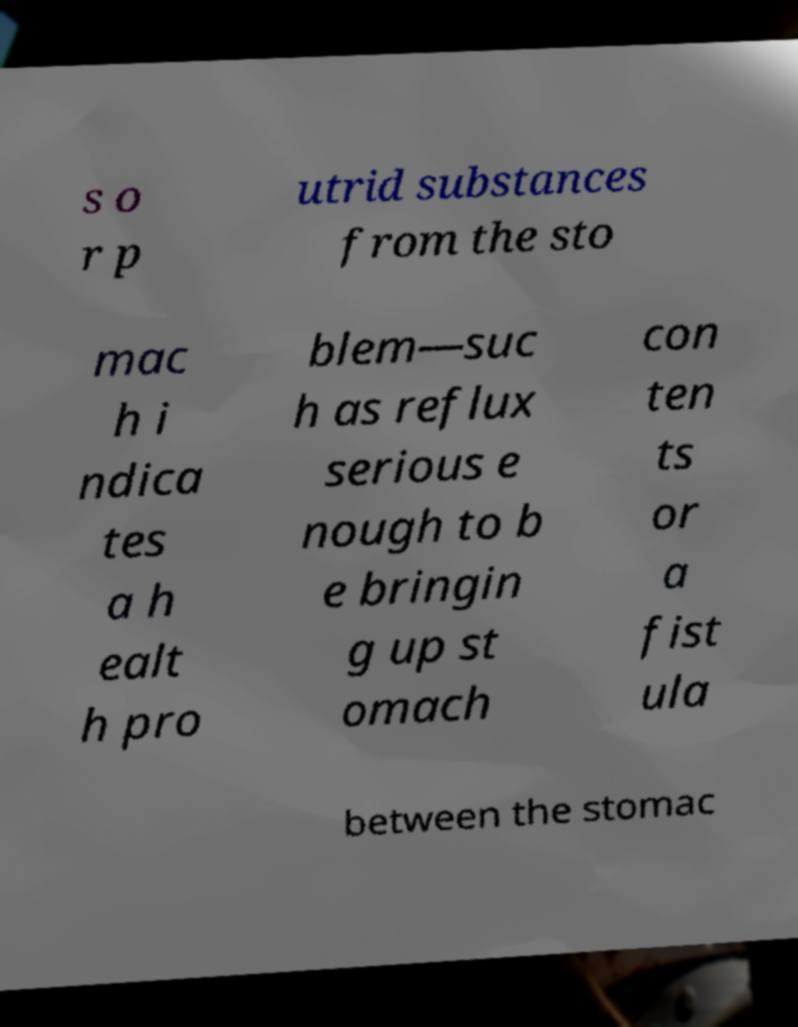Could you assist in decoding the text presented in this image and type it out clearly? s o r p utrid substances from the sto mac h i ndica tes a h ealt h pro blem—suc h as reflux serious e nough to b e bringin g up st omach con ten ts or a fist ula between the stomac 